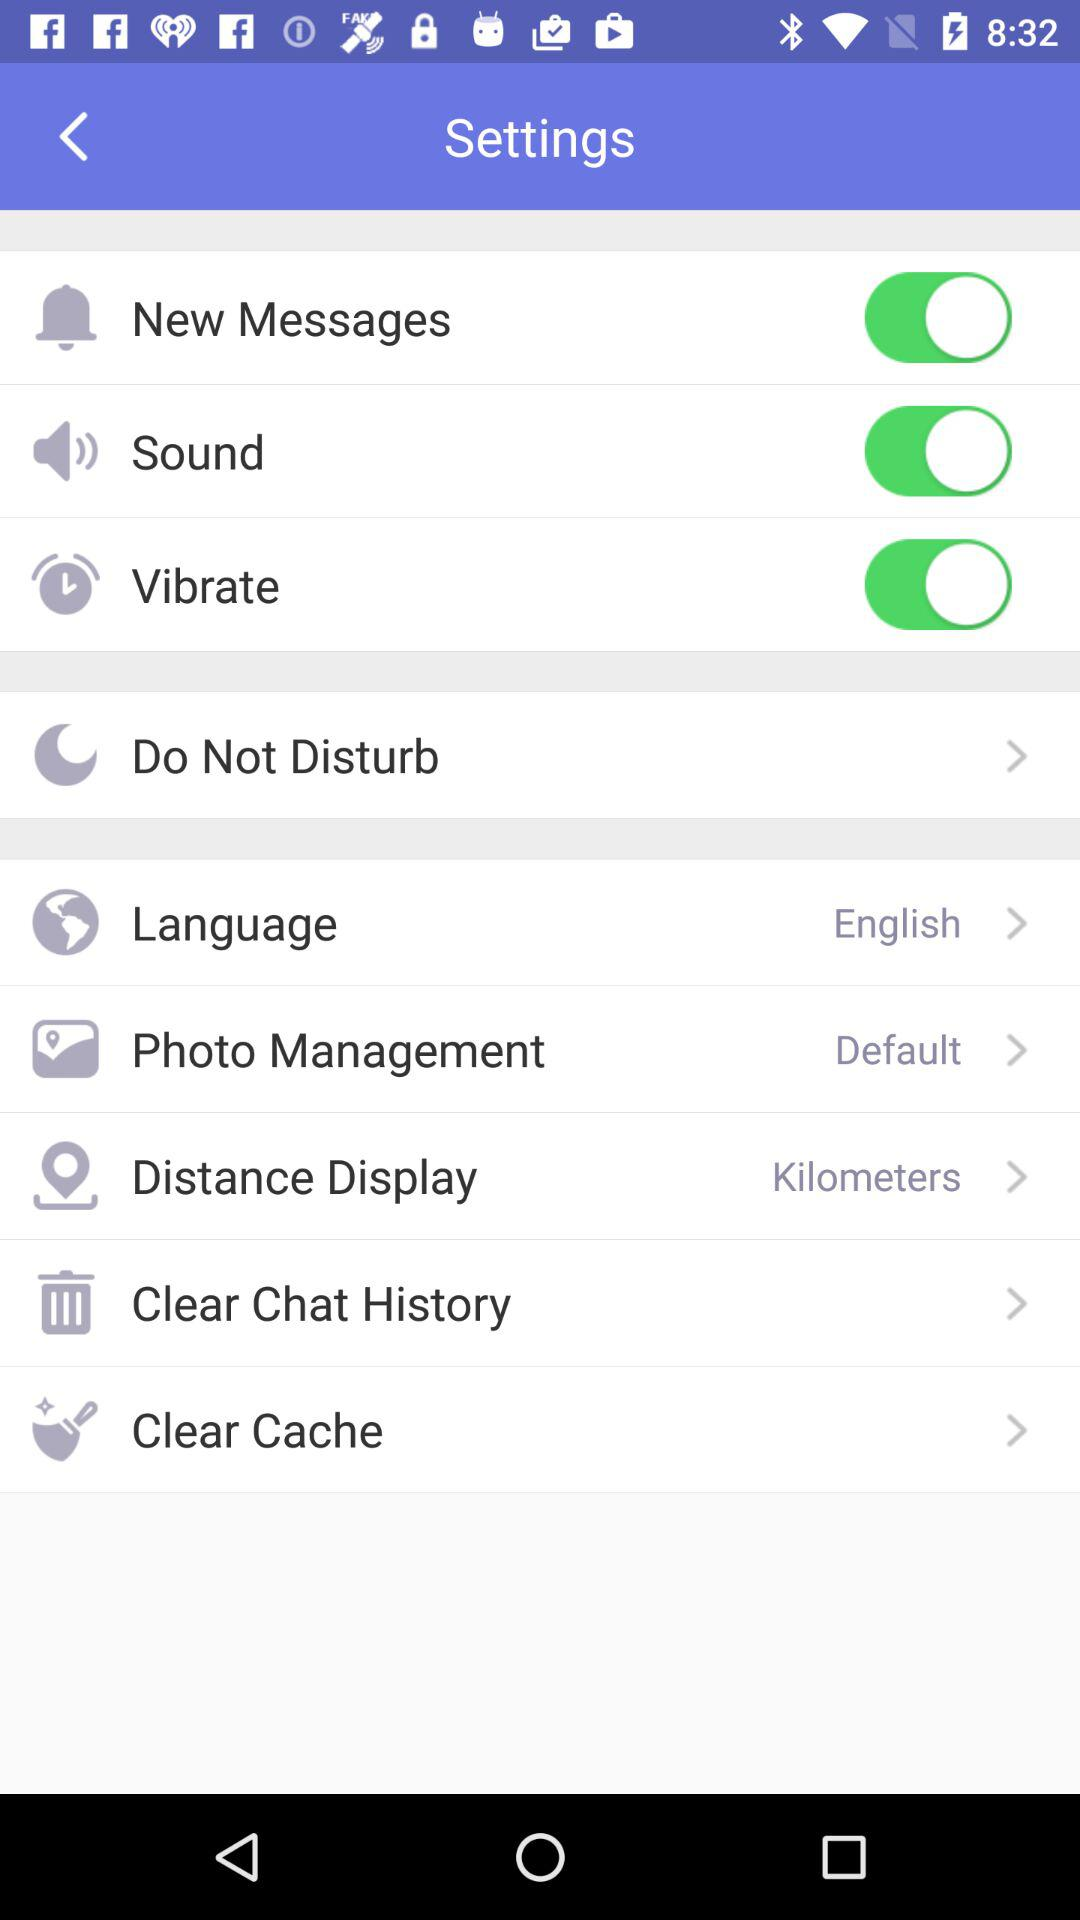Which photo management option has been chosen? The chosen option for photo management is "Default". 